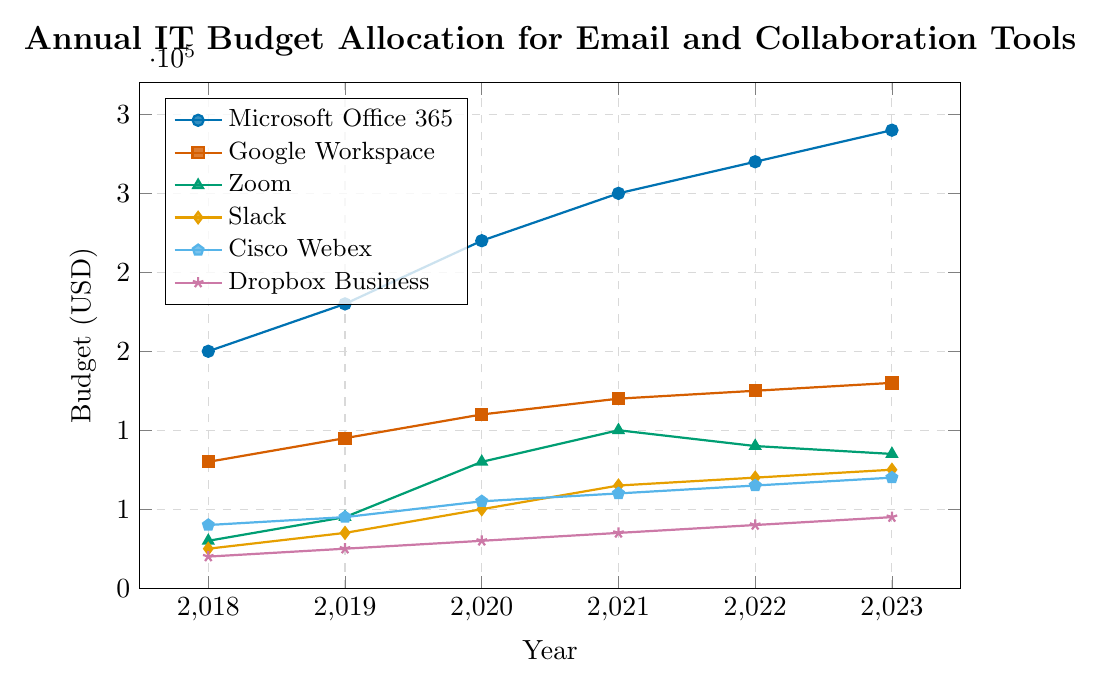Which year had the highest budget allocation for Microsoft Office 365? The highest point on the Microsoft Office 365 line is at the year 2023.
Answer: 2023 How much did the budget for Google Workspace increase from 2018 to 2023? Subtract the Google Workspace budget in 2018 from the budget in 2023: 130000 - 80000.
Answer: 50000 Which tool had the smallest budget in 2020? The lowest point on the different lines in 2020 corresponds to the Dropbox Business budget.
Answer: Dropbox Business In 2021, which had a higher budget allocation: Zoom or Slack? Compare the heights of the points on the Zoom and Slack lines in 2021. The Zoom budget is higher than Slack.
Answer: Zoom What was the total budget allocation for Cisco Webex from 2018 to 2023? Add the annual budgets for Cisco Webex: 40000 + 45000 + 55000 + 60000 + 65000 + 70000.
Answer: 335000 Which 2-year periods show the largest increase in the budget for Zoom? Compare the increase in budget for each 2-year period for Zoom: from 2018 to 2020 (80000 - 30000 = 50000), 2019 to 2021 (100000 - 45000 = 55000), 2020 to 2022 (90000 - 50000 = 40000), and 2021 to 2023 (85000 - 65000 = 20000). The largest increase is from 2019 to 2021.
Answer: 2019 to 2021 Is Slack's budget in 2023 greater than its budget in 2020 and 2021 combined? Compare Slack's budget in 2023 (75000) with the sum of its budgets in 2020 and 2021 (50000 + 65000 = 115000). The sum of 2020 and 2021 is greater than 2023's budget.
Answer: No How did the budget trend for Dropbox Business change from 2018 to 2023? Track the points on the Dropbox Business line from 2018 to 2023. The budget increased steadily each year from 20000 to 45000.
Answer: Increased steadily What is the average annual budget for Zoom between 2018 and 2023? Add the budgets for Zoom from 2018 to 2023 and divide by the number of years: (30000 + 45000 + 80000 + 100000 + 90000 + 85000) / 6.
Answer: 71667 By how much did the budget for Cisco Webex grow from 2018 to 2023? Subtract the Cisco Webex budget in 2018 from the budget in 2023: 70000 - 40000.
Answer: 30000 